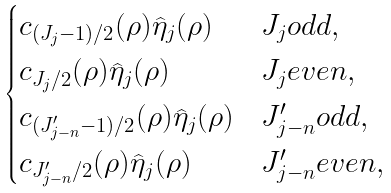<formula> <loc_0><loc_0><loc_500><loc_500>\begin{cases} c _ { ( J _ { j } - 1 ) / 2 } ( \rho ) \widehat { \eta } _ { j } ( \rho ) & J _ { j } o d d , \\ c _ { J _ { j } / 2 } ( \rho ) \widehat { \eta } _ { j } ( \rho ) & J _ { j } e v e n , \\ c _ { ( J ^ { \prime } _ { j - n } - 1 ) / 2 } ( \rho ) \widehat { \eta } _ { j } ( \rho ) & J ^ { \prime } _ { j - n } o d d , \\ c _ { J ^ { \prime } _ { j - n } / 2 } ( \rho ) \widehat { \eta } _ { j } ( \rho ) & J ^ { \prime } _ { j - n } e v e n , \end{cases}</formula> 